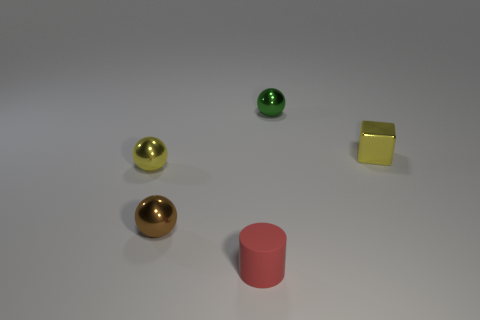Add 3 gray blocks. How many objects exist? 8 Subtract all balls. How many objects are left? 2 Subtract all green shiny spheres. Subtract all red rubber cylinders. How many objects are left? 3 Add 4 tiny yellow metal balls. How many tiny yellow metal balls are left? 5 Add 1 red matte objects. How many red matte objects exist? 2 Subtract 0 blue cylinders. How many objects are left? 5 